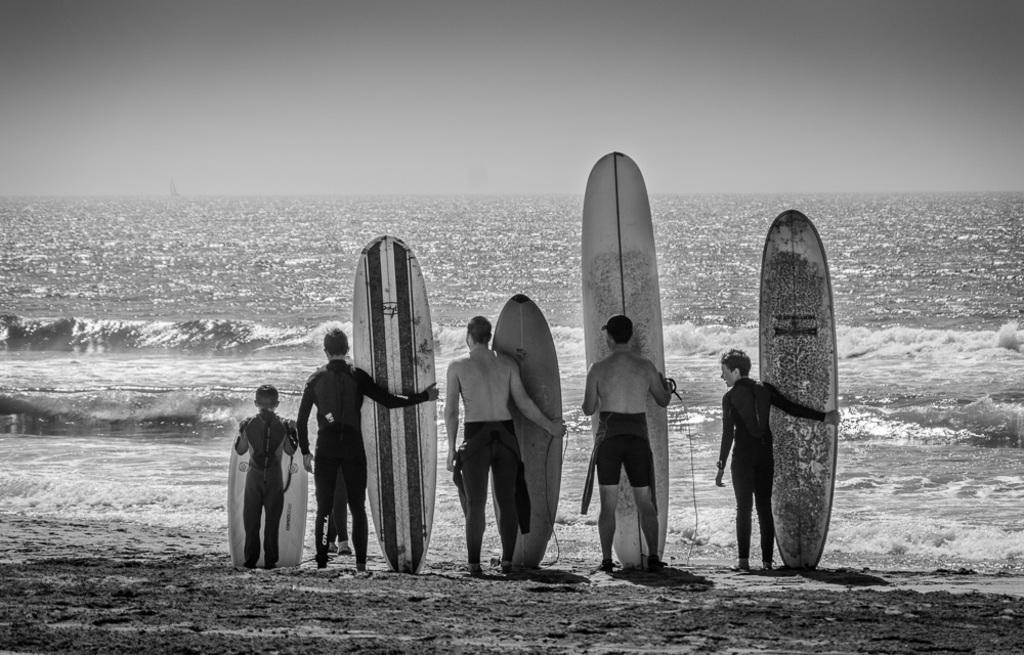How would you summarize this image in a sentence or two? In this image there are group of persons standing on the beach holding surfing boards and at the background of the image there is a ocean. 